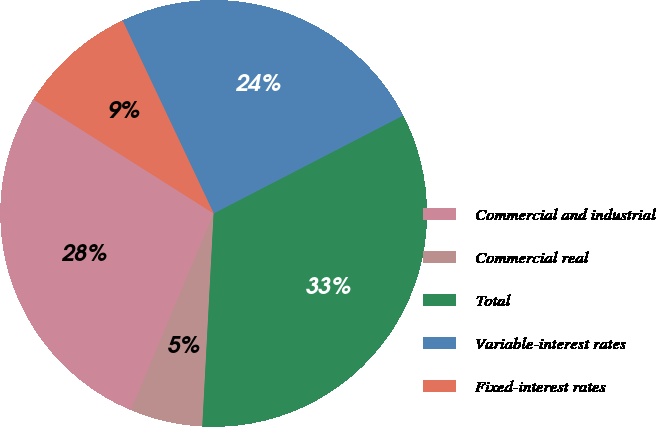<chart> <loc_0><loc_0><loc_500><loc_500><pie_chart><fcel>Commercial and industrial<fcel>Commercial real<fcel>Total<fcel>Variable-interest rates<fcel>Fixed-interest rates<nl><fcel>27.64%<fcel>5.49%<fcel>33.44%<fcel>24.43%<fcel>9.0%<nl></chart> 